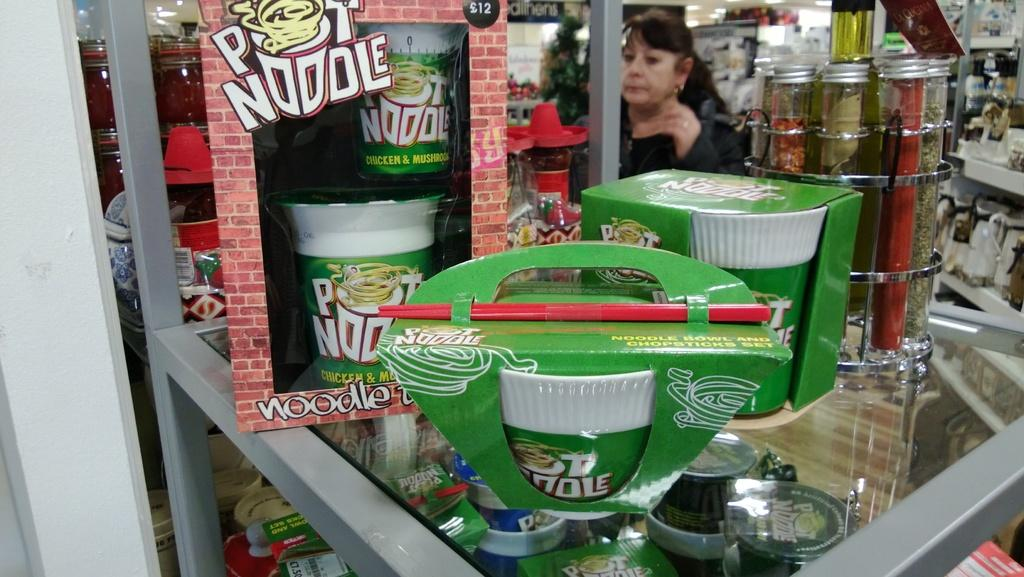What type of food is visible in the image? There are packs of noodles in the image. Can you describe the person present in the image? There is a woman present at the back of the image. What other objects can be seen in the image besides the packs of noodles and the woman? There are other objects in the image, but their specific details are not mentioned in the provided facts. What type of crime is being committed in the image? There is no indication of any crime being committed in the image. What is the limit of the noodles in the image? The limit of the noodles cannot be determined from the image, as it only shows packs of noodles and does not provide any information about their quantity or size. 